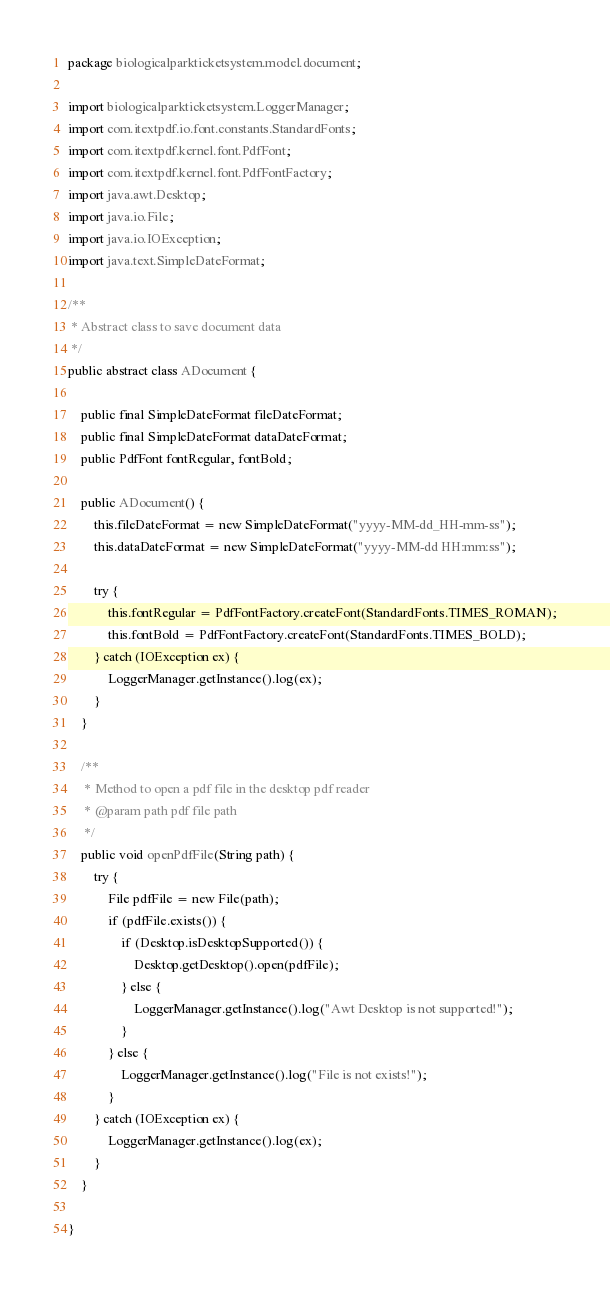Convert code to text. <code><loc_0><loc_0><loc_500><loc_500><_Java_>package biologicalparkticketsystem.model.document;

import biologicalparkticketsystem.LoggerManager;
import com.itextpdf.io.font.constants.StandardFonts;
import com.itextpdf.kernel.font.PdfFont;
import com.itextpdf.kernel.font.PdfFontFactory;
import java.awt.Desktop;
import java.io.File;
import java.io.IOException;
import java.text.SimpleDateFormat;

/**
 * Abstract class to save document data
 */
public abstract class ADocument {
    
    public final SimpleDateFormat fileDateFormat;
    public final SimpleDateFormat dataDateFormat;
    public PdfFont fontRegular, fontBold;
    
    public ADocument() {
        this.fileDateFormat = new SimpleDateFormat("yyyy-MM-dd_HH-mm-ss");
        this.dataDateFormat = new SimpleDateFormat("yyyy-MM-dd HH:mm:ss");
        
        try {
            this.fontRegular = PdfFontFactory.createFont(StandardFonts.TIMES_ROMAN);
            this.fontBold = PdfFontFactory.createFont(StandardFonts.TIMES_BOLD);
        } catch (IOException ex) {
            LoggerManager.getInstance().log(ex);
        }
    }
    
    /**
     * Method to open a pdf file in the desktop pdf reader
     * @param path pdf file path
     */
    public void openPdfFile(String path) {
        try {
            File pdfFile = new File(path);
            if (pdfFile.exists()) {
                if (Desktop.isDesktopSupported()) {
                    Desktop.getDesktop().open(pdfFile);
                } else {
                    LoggerManager.getInstance().log("Awt Desktop is not supported!");
                }
            } else {
                LoggerManager.getInstance().log("File is not exists!");
            }
        } catch (IOException ex) {
            LoggerManager.getInstance().log(ex);
        }
    }
    
}
</code> 